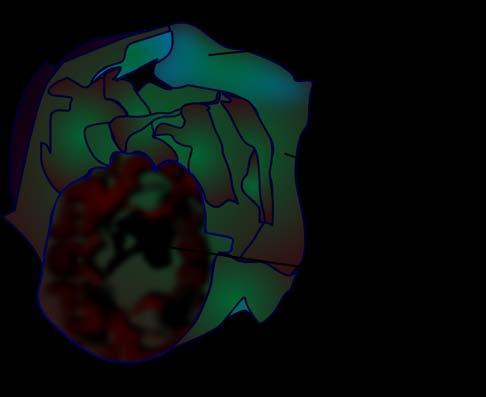does cut surface show a very large multilocular cyst without papillae?
Answer the question using a single word or phrase. Yes 